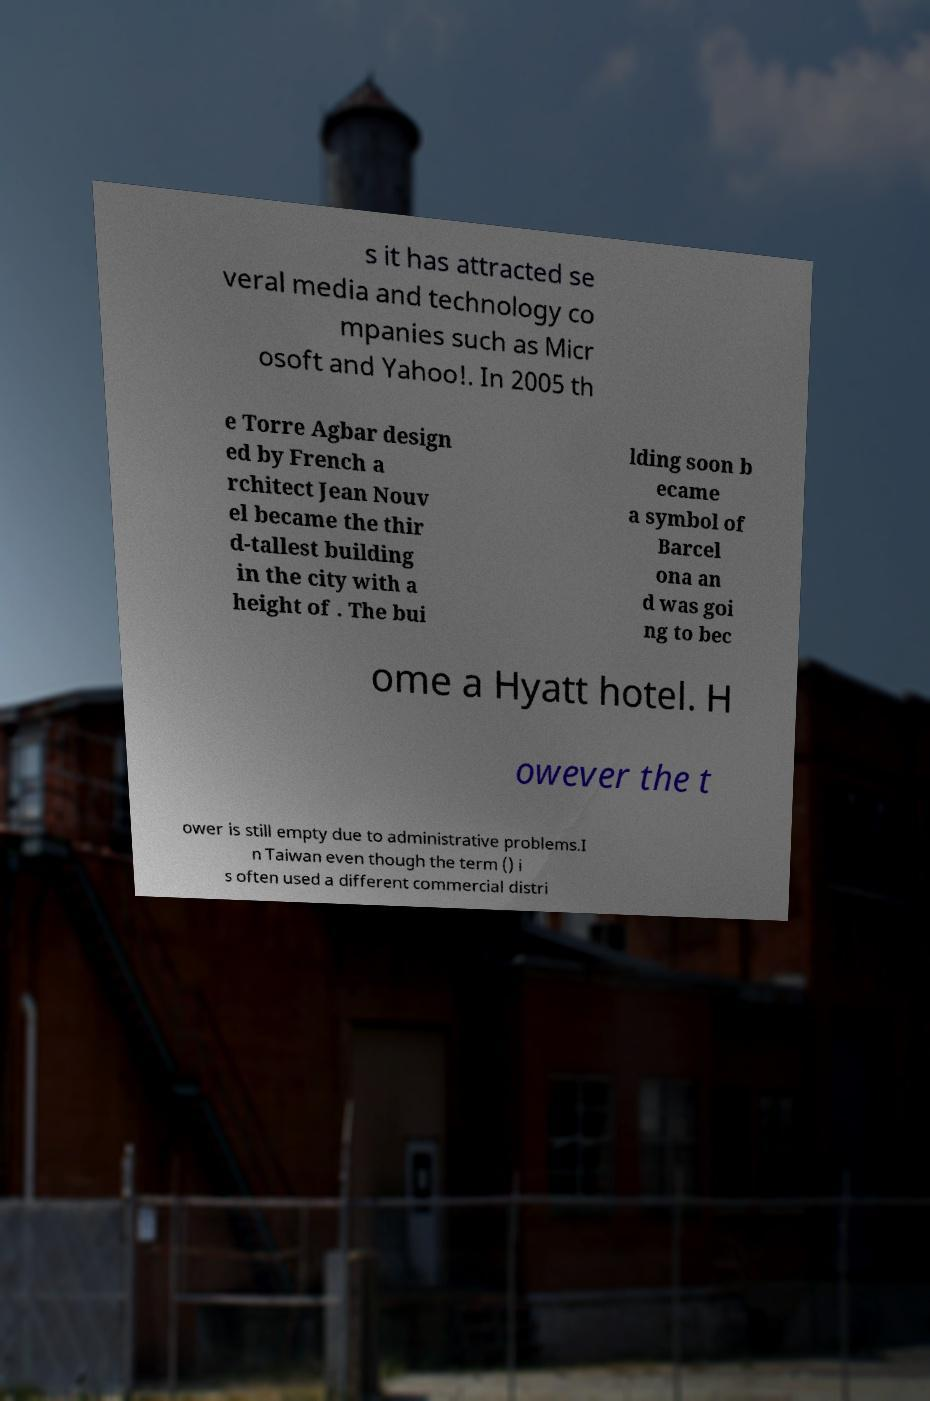There's text embedded in this image that I need extracted. Can you transcribe it verbatim? s it has attracted se veral media and technology co mpanies such as Micr osoft and Yahoo!. In 2005 th e Torre Agbar design ed by French a rchitect Jean Nouv el became the thir d-tallest building in the city with a height of . The bui lding soon b ecame a symbol of Barcel ona an d was goi ng to bec ome a Hyatt hotel. H owever the t ower is still empty due to administrative problems.I n Taiwan even though the term () i s often used a different commercial distri 